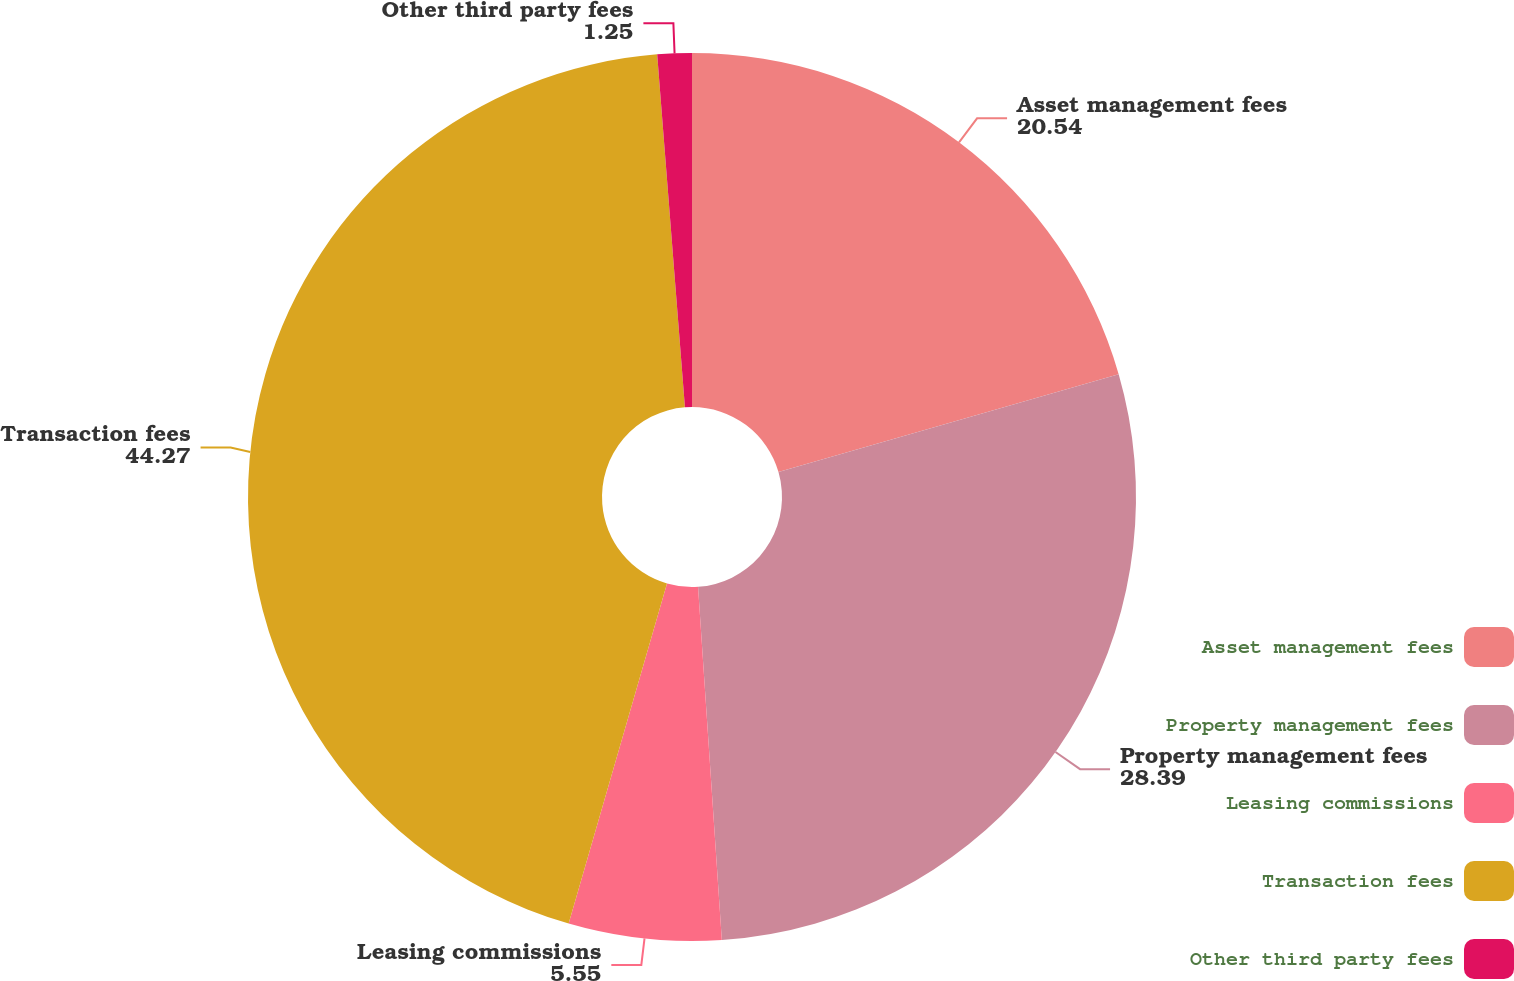<chart> <loc_0><loc_0><loc_500><loc_500><pie_chart><fcel>Asset management fees<fcel>Property management fees<fcel>Leasing commissions<fcel>Transaction fees<fcel>Other third party fees<nl><fcel>20.54%<fcel>28.39%<fcel>5.55%<fcel>44.27%<fcel>1.25%<nl></chart> 